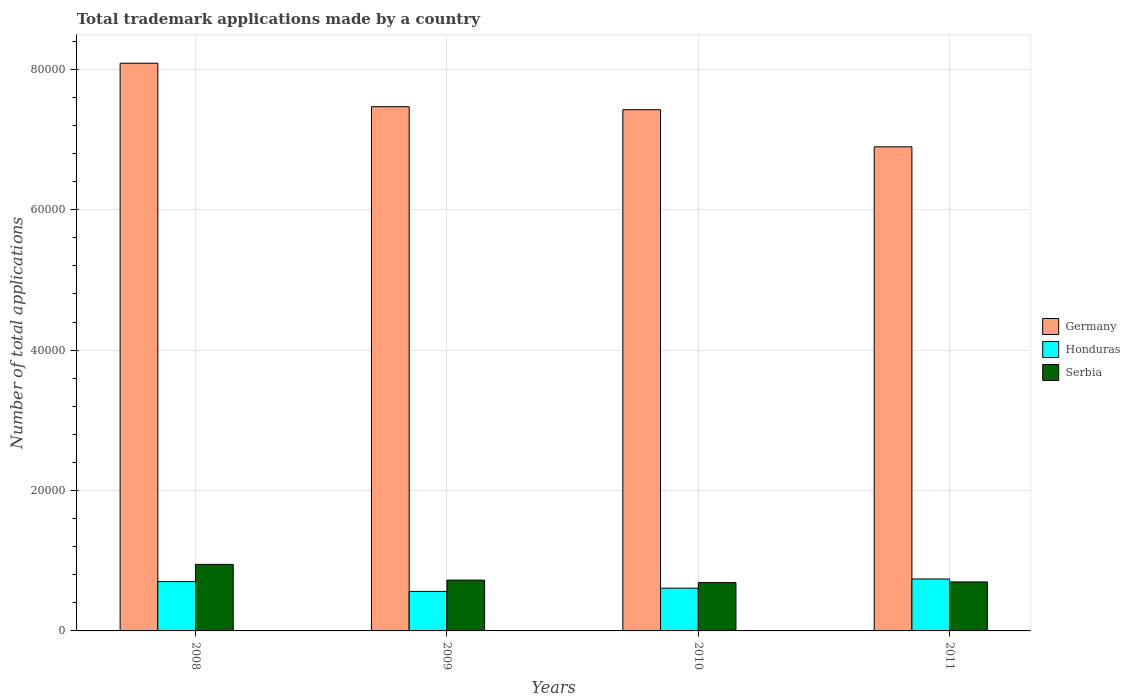Are the number of bars per tick equal to the number of legend labels?
Your answer should be compact. Yes. In how many cases, is the number of bars for a given year not equal to the number of legend labels?
Give a very brief answer. 0. What is the number of applications made by in Germany in 2009?
Ensure brevity in your answer.  7.47e+04. Across all years, what is the maximum number of applications made by in Germany?
Make the answer very short. 8.09e+04. Across all years, what is the minimum number of applications made by in Serbia?
Provide a succinct answer. 6885. In which year was the number of applications made by in Serbia maximum?
Provide a short and direct response. 2008. What is the total number of applications made by in Germany in the graph?
Provide a short and direct response. 2.99e+05. What is the difference between the number of applications made by in Serbia in 2008 and that in 2009?
Provide a succinct answer. 2242. What is the difference between the number of applications made by in Serbia in 2008 and the number of applications made by in Germany in 2009?
Provide a succinct answer. -6.52e+04. What is the average number of applications made by in Honduras per year?
Provide a short and direct response. 6536.75. In the year 2008, what is the difference between the number of applications made by in Serbia and number of applications made by in Germany?
Provide a succinct answer. -7.14e+04. In how many years, is the number of applications made by in Honduras greater than 72000?
Give a very brief answer. 0. What is the ratio of the number of applications made by in Germany in 2008 to that in 2009?
Offer a terse response. 1.08. Is the number of applications made by in Honduras in 2009 less than that in 2011?
Offer a very short reply. Yes. What is the difference between the highest and the second highest number of applications made by in Germany?
Keep it short and to the point. 6189. What is the difference between the highest and the lowest number of applications made by in Germany?
Give a very brief answer. 1.19e+04. In how many years, is the number of applications made by in Honduras greater than the average number of applications made by in Honduras taken over all years?
Make the answer very short. 2. How many bars are there?
Offer a terse response. 12. How many years are there in the graph?
Offer a very short reply. 4. What is the difference between two consecutive major ticks on the Y-axis?
Your response must be concise. 2.00e+04. Does the graph contain any zero values?
Offer a terse response. No. What is the title of the graph?
Make the answer very short. Total trademark applications made by a country. What is the label or title of the Y-axis?
Provide a succinct answer. Number of total applications. What is the Number of total applications in Germany in 2008?
Your answer should be compact. 8.09e+04. What is the Number of total applications of Honduras in 2008?
Provide a succinct answer. 7032. What is the Number of total applications of Serbia in 2008?
Offer a terse response. 9479. What is the Number of total applications of Germany in 2009?
Offer a very short reply. 7.47e+04. What is the Number of total applications of Honduras in 2009?
Your answer should be very brief. 5629. What is the Number of total applications in Serbia in 2009?
Offer a terse response. 7237. What is the Number of total applications in Germany in 2010?
Provide a short and direct response. 7.42e+04. What is the Number of total applications in Honduras in 2010?
Offer a very short reply. 6089. What is the Number of total applications in Serbia in 2010?
Your answer should be very brief. 6885. What is the Number of total applications of Germany in 2011?
Ensure brevity in your answer.  6.90e+04. What is the Number of total applications of Honduras in 2011?
Your answer should be very brief. 7397. What is the Number of total applications in Serbia in 2011?
Provide a succinct answer. 6979. Across all years, what is the maximum Number of total applications of Germany?
Offer a terse response. 8.09e+04. Across all years, what is the maximum Number of total applications in Honduras?
Offer a terse response. 7397. Across all years, what is the maximum Number of total applications in Serbia?
Ensure brevity in your answer.  9479. Across all years, what is the minimum Number of total applications of Germany?
Your answer should be very brief. 6.90e+04. Across all years, what is the minimum Number of total applications of Honduras?
Keep it short and to the point. 5629. Across all years, what is the minimum Number of total applications of Serbia?
Give a very brief answer. 6885. What is the total Number of total applications of Germany in the graph?
Your answer should be very brief. 2.99e+05. What is the total Number of total applications in Honduras in the graph?
Your answer should be compact. 2.61e+04. What is the total Number of total applications of Serbia in the graph?
Keep it short and to the point. 3.06e+04. What is the difference between the Number of total applications of Germany in 2008 and that in 2009?
Keep it short and to the point. 6189. What is the difference between the Number of total applications in Honduras in 2008 and that in 2009?
Your answer should be very brief. 1403. What is the difference between the Number of total applications in Serbia in 2008 and that in 2009?
Offer a terse response. 2242. What is the difference between the Number of total applications in Germany in 2008 and that in 2010?
Provide a short and direct response. 6617. What is the difference between the Number of total applications in Honduras in 2008 and that in 2010?
Your answer should be very brief. 943. What is the difference between the Number of total applications in Serbia in 2008 and that in 2010?
Make the answer very short. 2594. What is the difference between the Number of total applications of Germany in 2008 and that in 2011?
Provide a succinct answer. 1.19e+04. What is the difference between the Number of total applications of Honduras in 2008 and that in 2011?
Provide a succinct answer. -365. What is the difference between the Number of total applications in Serbia in 2008 and that in 2011?
Offer a terse response. 2500. What is the difference between the Number of total applications in Germany in 2009 and that in 2010?
Offer a terse response. 428. What is the difference between the Number of total applications of Honduras in 2009 and that in 2010?
Your response must be concise. -460. What is the difference between the Number of total applications in Serbia in 2009 and that in 2010?
Provide a short and direct response. 352. What is the difference between the Number of total applications of Germany in 2009 and that in 2011?
Ensure brevity in your answer.  5715. What is the difference between the Number of total applications of Honduras in 2009 and that in 2011?
Ensure brevity in your answer.  -1768. What is the difference between the Number of total applications of Serbia in 2009 and that in 2011?
Ensure brevity in your answer.  258. What is the difference between the Number of total applications of Germany in 2010 and that in 2011?
Provide a succinct answer. 5287. What is the difference between the Number of total applications in Honduras in 2010 and that in 2011?
Provide a succinct answer. -1308. What is the difference between the Number of total applications in Serbia in 2010 and that in 2011?
Your answer should be very brief. -94. What is the difference between the Number of total applications in Germany in 2008 and the Number of total applications in Honduras in 2009?
Offer a terse response. 7.52e+04. What is the difference between the Number of total applications of Germany in 2008 and the Number of total applications of Serbia in 2009?
Your answer should be very brief. 7.36e+04. What is the difference between the Number of total applications of Honduras in 2008 and the Number of total applications of Serbia in 2009?
Offer a very short reply. -205. What is the difference between the Number of total applications in Germany in 2008 and the Number of total applications in Honduras in 2010?
Offer a terse response. 7.48e+04. What is the difference between the Number of total applications in Germany in 2008 and the Number of total applications in Serbia in 2010?
Make the answer very short. 7.40e+04. What is the difference between the Number of total applications of Honduras in 2008 and the Number of total applications of Serbia in 2010?
Provide a succinct answer. 147. What is the difference between the Number of total applications of Germany in 2008 and the Number of total applications of Honduras in 2011?
Give a very brief answer. 7.35e+04. What is the difference between the Number of total applications in Germany in 2008 and the Number of total applications in Serbia in 2011?
Ensure brevity in your answer.  7.39e+04. What is the difference between the Number of total applications of Honduras in 2008 and the Number of total applications of Serbia in 2011?
Offer a terse response. 53. What is the difference between the Number of total applications in Germany in 2009 and the Number of total applications in Honduras in 2010?
Provide a succinct answer. 6.86e+04. What is the difference between the Number of total applications in Germany in 2009 and the Number of total applications in Serbia in 2010?
Your answer should be very brief. 6.78e+04. What is the difference between the Number of total applications of Honduras in 2009 and the Number of total applications of Serbia in 2010?
Give a very brief answer. -1256. What is the difference between the Number of total applications in Germany in 2009 and the Number of total applications in Honduras in 2011?
Provide a short and direct response. 6.73e+04. What is the difference between the Number of total applications of Germany in 2009 and the Number of total applications of Serbia in 2011?
Your answer should be compact. 6.77e+04. What is the difference between the Number of total applications of Honduras in 2009 and the Number of total applications of Serbia in 2011?
Your answer should be very brief. -1350. What is the difference between the Number of total applications of Germany in 2010 and the Number of total applications of Honduras in 2011?
Your response must be concise. 6.69e+04. What is the difference between the Number of total applications in Germany in 2010 and the Number of total applications in Serbia in 2011?
Your response must be concise. 6.73e+04. What is the difference between the Number of total applications of Honduras in 2010 and the Number of total applications of Serbia in 2011?
Give a very brief answer. -890. What is the average Number of total applications in Germany per year?
Your response must be concise. 7.47e+04. What is the average Number of total applications of Honduras per year?
Your response must be concise. 6536.75. What is the average Number of total applications in Serbia per year?
Ensure brevity in your answer.  7645. In the year 2008, what is the difference between the Number of total applications of Germany and Number of total applications of Honduras?
Offer a terse response. 7.38e+04. In the year 2008, what is the difference between the Number of total applications of Germany and Number of total applications of Serbia?
Your response must be concise. 7.14e+04. In the year 2008, what is the difference between the Number of total applications in Honduras and Number of total applications in Serbia?
Offer a very short reply. -2447. In the year 2009, what is the difference between the Number of total applications in Germany and Number of total applications in Honduras?
Give a very brief answer. 6.90e+04. In the year 2009, what is the difference between the Number of total applications in Germany and Number of total applications in Serbia?
Your answer should be very brief. 6.74e+04. In the year 2009, what is the difference between the Number of total applications in Honduras and Number of total applications in Serbia?
Your response must be concise. -1608. In the year 2010, what is the difference between the Number of total applications in Germany and Number of total applications in Honduras?
Your response must be concise. 6.82e+04. In the year 2010, what is the difference between the Number of total applications of Germany and Number of total applications of Serbia?
Your answer should be compact. 6.74e+04. In the year 2010, what is the difference between the Number of total applications in Honduras and Number of total applications in Serbia?
Keep it short and to the point. -796. In the year 2011, what is the difference between the Number of total applications in Germany and Number of total applications in Honduras?
Provide a succinct answer. 6.16e+04. In the year 2011, what is the difference between the Number of total applications of Germany and Number of total applications of Serbia?
Provide a succinct answer. 6.20e+04. In the year 2011, what is the difference between the Number of total applications of Honduras and Number of total applications of Serbia?
Provide a succinct answer. 418. What is the ratio of the Number of total applications in Germany in 2008 to that in 2009?
Offer a terse response. 1.08. What is the ratio of the Number of total applications of Honduras in 2008 to that in 2009?
Your answer should be compact. 1.25. What is the ratio of the Number of total applications in Serbia in 2008 to that in 2009?
Offer a terse response. 1.31. What is the ratio of the Number of total applications in Germany in 2008 to that in 2010?
Make the answer very short. 1.09. What is the ratio of the Number of total applications of Honduras in 2008 to that in 2010?
Your answer should be compact. 1.15. What is the ratio of the Number of total applications of Serbia in 2008 to that in 2010?
Keep it short and to the point. 1.38. What is the ratio of the Number of total applications of Germany in 2008 to that in 2011?
Ensure brevity in your answer.  1.17. What is the ratio of the Number of total applications of Honduras in 2008 to that in 2011?
Provide a succinct answer. 0.95. What is the ratio of the Number of total applications of Serbia in 2008 to that in 2011?
Ensure brevity in your answer.  1.36. What is the ratio of the Number of total applications of Germany in 2009 to that in 2010?
Your answer should be compact. 1.01. What is the ratio of the Number of total applications of Honduras in 2009 to that in 2010?
Provide a short and direct response. 0.92. What is the ratio of the Number of total applications of Serbia in 2009 to that in 2010?
Provide a short and direct response. 1.05. What is the ratio of the Number of total applications of Germany in 2009 to that in 2011?
Your response must be concise. 1.08. What is the ratio of the Number of total applications of Honduras in 2009 to that in 2011?
Provide a short and direct response. 0.76. What is the ratio of the Number of total applications in Serbia in 2009 to that in 2011?
Offer a very short reply. 1.04. What is the ratio of the Number of total applications in Germany in 2010 to that in 2011?
Your answer should be compact. 1.08. What is the ratio of the Number of total applications of Honduras in 2010 to that in 2011?
Offer a very short reply. 0.82. What is the ratio of the Number of total applications in Serbia in 2010 to that in 2011?
Ensure brevity in your answer.  0.99. What is the difference between the highest and the second highest Number of total applications in Germany?
Your answer should be very brief. 6189. What is the difference between the highest and the second highest Number of total applications of Honduras?
Provide a short and direct response. 365. What is the difference between the highest and the second highest Number of total applications in Serbia?
Give a very brief answer. 2242. What is the difference between the highest and the lowest Number of total applications of Germany?
Offer a very short reply. 1.19e+04. What is the difference between the highest and the lowest Number of total applications in Honduras?
Give a very brief answer. 1768. What is the difference between the highest and the lowest Number of total applications of Serbia?
Your response must be concise. 2594. 